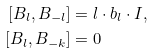Convert formula to latex. <formula><loc_0><loc_0><loc_500><loc_500>[ B _ { l } , B _ { - l } ] & = l \cdot b _ { l } \cdot I , \\ [ B _ { l } , B _ { - k } ] & = 0</formula> 